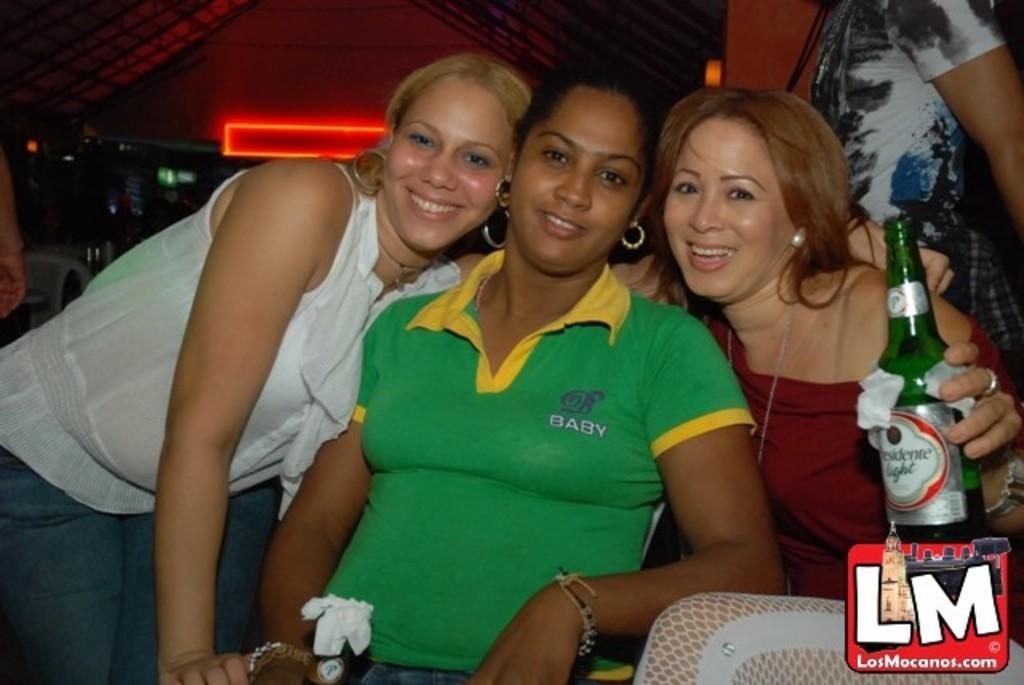Could you give a brief overview of what you see in this image? In the image there are three women and one of right side holding beer bottle and back side of him there is red neon light. 